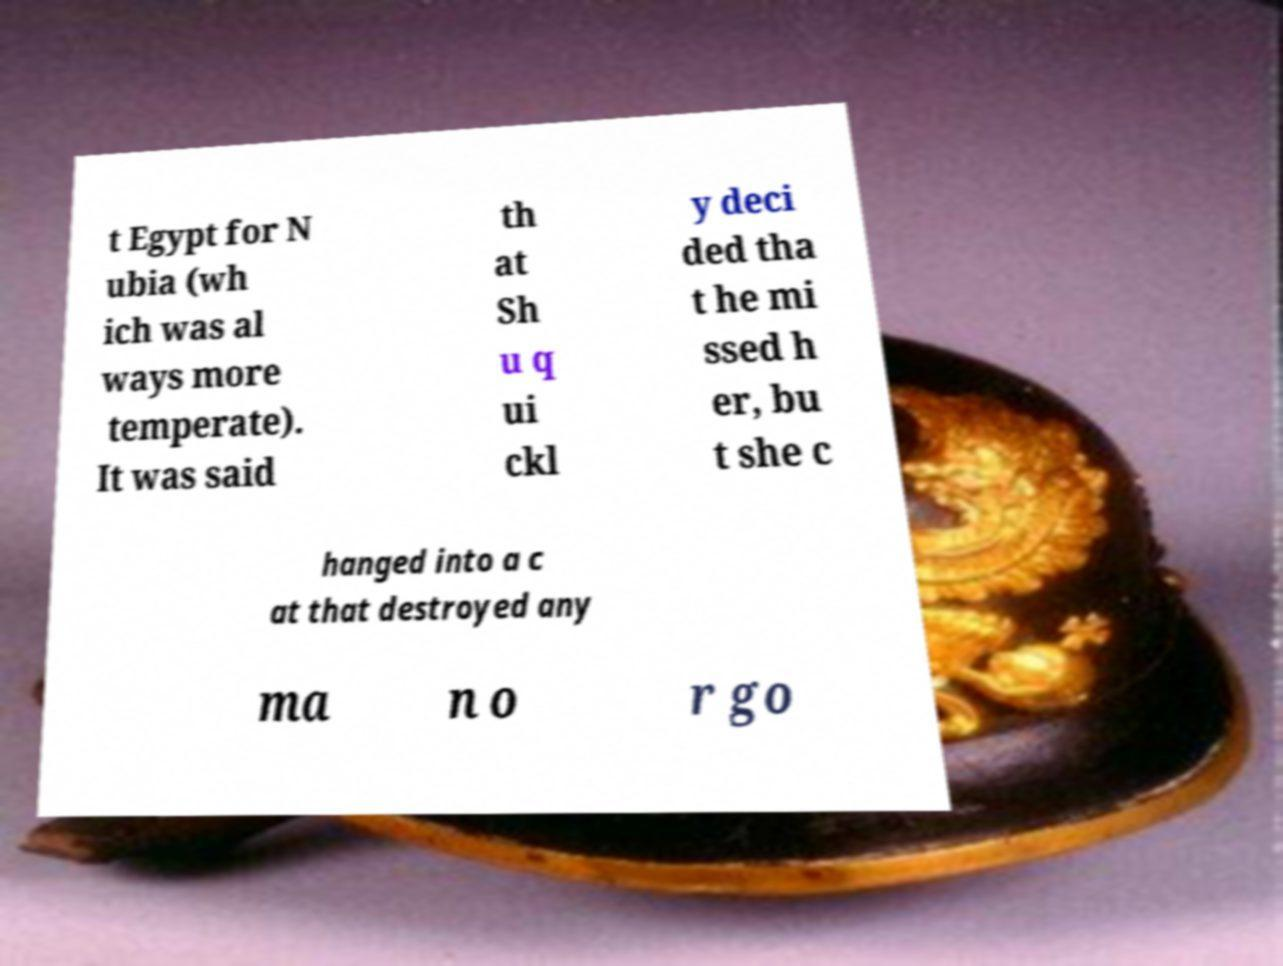Could you extract and type out the text from this image? t Egypt for N ubia (wh ich was al ways more temperate). It was said th at Sh u q ui ckl y deci ded tha t he mi ssed h er, bu t she c hanged into a c at that destroyed any ma n o r go 